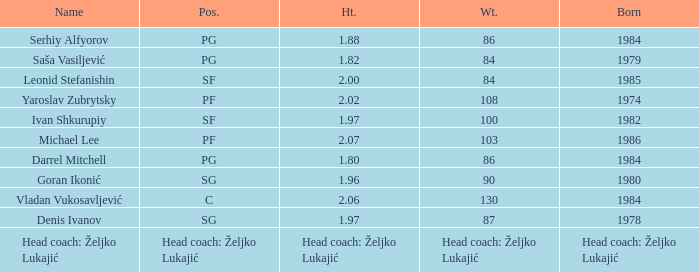What is the weight of the player with a height of 2.00m? 84.0. Would you mind parsing the complete table? {'header': ['Name', 'Pos.', 'Ht.', 'Wt.', 'Born'], 'rows': [['Serhiy Alfyorov', 'PG', '1.88', '86', '1984'], ['Saša Vasiljević', 'PG', '1.82', '84', '1979'], ['Leonid Stefanishin', 'SF', '2.00', '84', '1985'], ['Yaroslav Zubrytsky', 'PF', '2.02', '108', '1974'], ['Ivan Shkurupiy', 'SF', '1.97', '100', '1982'], ['Michael Lee', 'PF', '2.07', '103', '1986'], ['Darrel Mitchell', 'PG', '1.80', '86', '1984'], ['Goran Ikonić', 'SG', '1.96', '90', '1980'], ['Vladan Vukosavljević', 'C', '2.06', '130', '1984'], ['Denis Ivanov', 'SG', '1.97', '87', '1978'], ['Head coach: Željko Lukajić', 'Head coach: Željko Lukajić', 'Head coach: Željko Lukajić', 'Head coach: Željko Lukajić', 'Head coach: Željko Lukajić']]} 